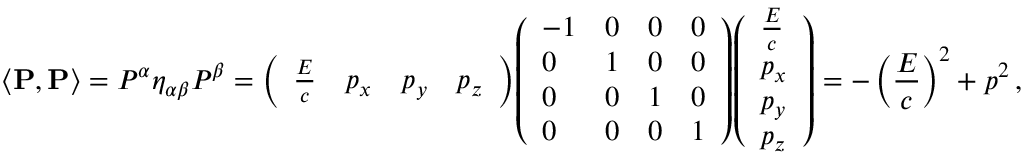Convert formula to latex. <formula><loc_0><loc_0><loc_500><loc_500>\left \langle P , P \right \rangle = P ^ { \alpha } \eta _ { \alpha \beta } P ^ { \beta } = { \left ( \begin{array} { l l l l } { { \frac { E } { c } } } & { p _ { x } } & { p _ { y } } & { p _ { z } } \end{array} \right ) } { \left ( \begin{array} { l l l l } { - 1 } & { 0 } & { 0 } & { 0 } \\ { 0 } & { 1 } & { 0 } & { 0 } \\ { 0 } & { 0 } & { 1 } & { 0 } \\ { 0 } & { 0 } & { 0 } & { 1 } \end{array} \right ) } { \left ( \begin{array} { l } { { \frac { E } { c } } } \\ { p _ { x } } \\ { p _ { y } } \\ { p _ { z } } \end{array} \right ) } = - \left ( { \frac { E } { c } } \right ) ^ { 2 } + p ^ { 2 } \, ,</formula> 